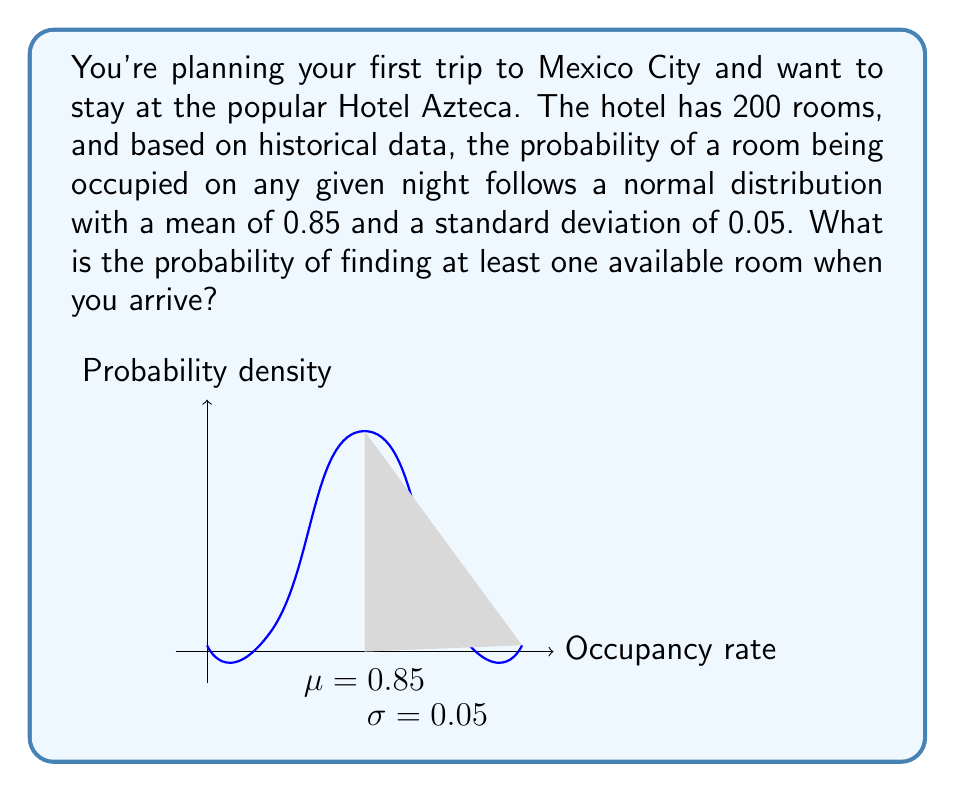Could you help me with this problem? Let's approach this step-by-step:

1) First, we need to realize that finding at least one available room is the complement of all rooms being occupied. So, we'll calculate the probability of all rooms being occupied and subtract it from 1.

2) The probability of all rooms being occupied is equivalent to the probability that the occupancy rate is 1 (or 100%).

3) We're given that the occupancy rate follows a normal distribution with $\mu = 0.85$ and $\sigma = 0.05$.

4) To find the probability that the occupancy rate is less than 1, we need to calculate the z-score for an occupancy rate of 1:

   $$z = \frac{x - \mu}{\sigma} = \frac{1 - 0.85}{0.05} = 3$$

5) Now we need to find the probability that z is less than 3. We can use a standard normal table or a calculator for this.

   $$P(Z < 3) \approx 0.9987$$

6) This means the probability of all rooms being occupied is approximately 0.0013 (1 - 0.9987).

7) Therefore, the probability of finding at least one available room is:

   $$1 - 0.0013 = 0.9987$$
Answer: 0.9987 